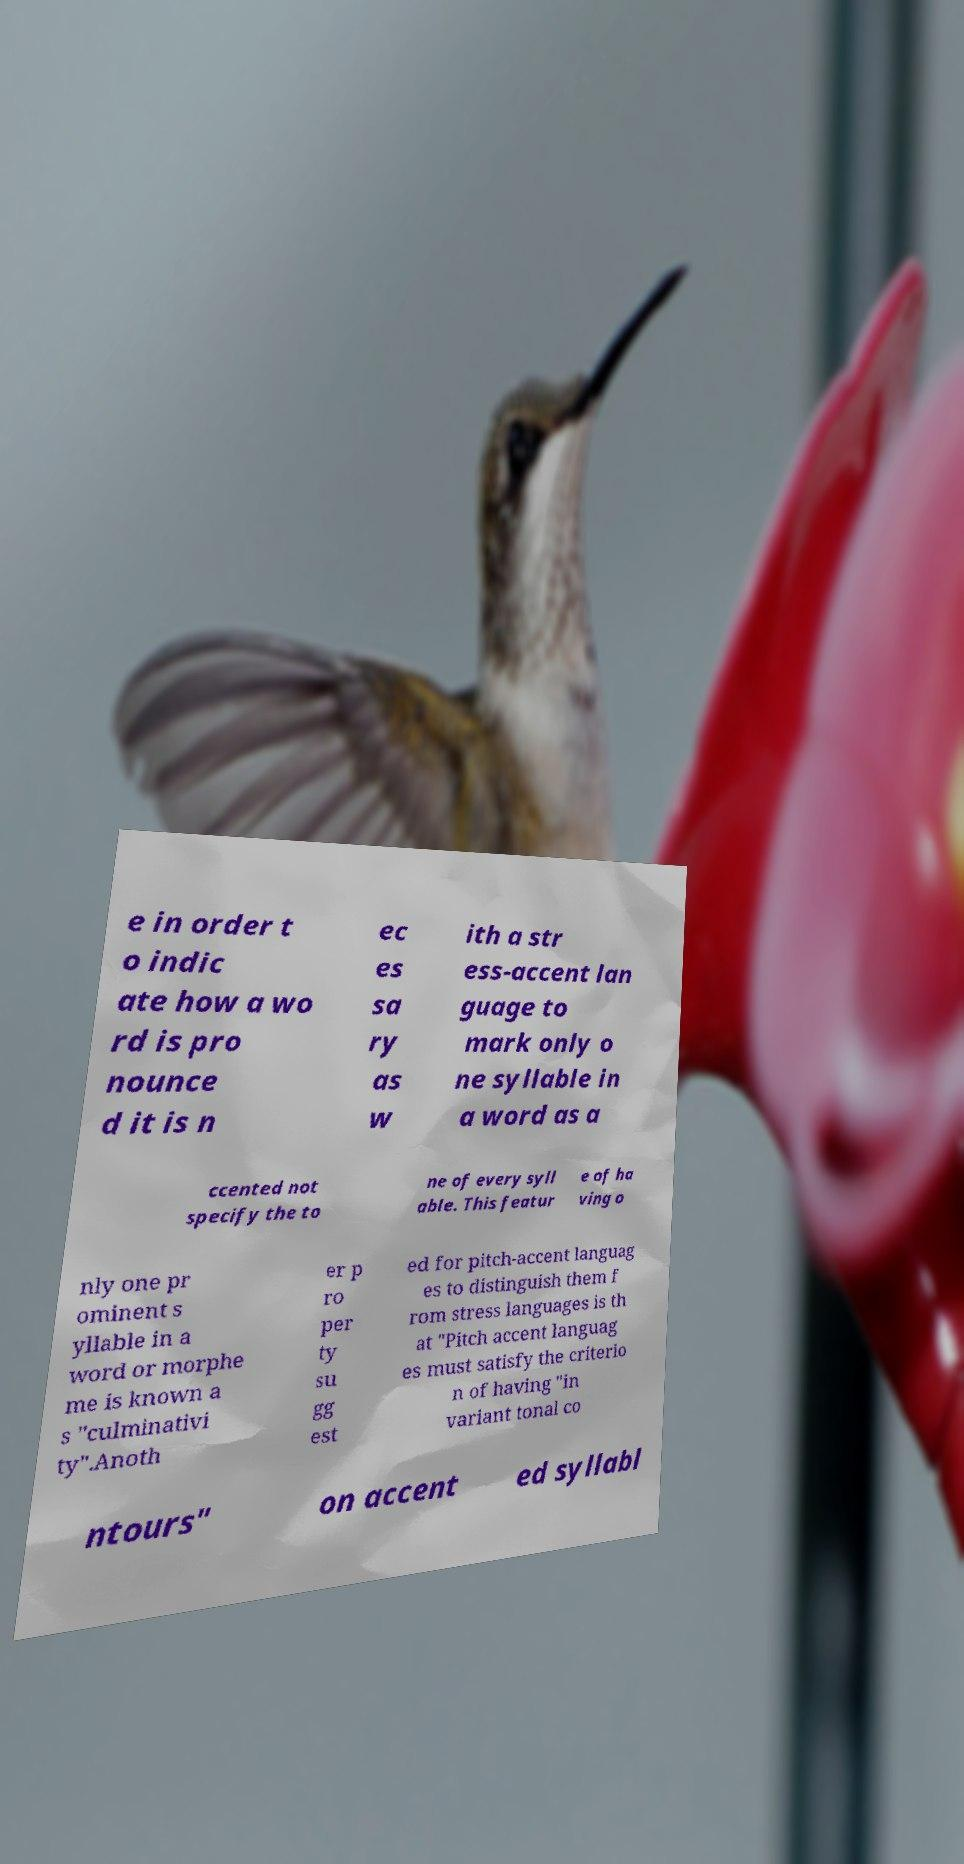I need the written content from this picture converted into text. Can you do that? e in order t o indic ate how a wo rd is pro nounce d it is n ec es sa ry as w ith a str ess-accent lan guage to mark only o ne syllable in a word as a ccented not specify the to ne of every syll able. This featur e of ha ving o nly one pr ominent s yllable in a word or morphe me is known a s "culminativi ty".Anoth er p ro per ty su gg est ed for pitch-accent languag es to distinguish them f rom stress languages is th at "Pitch accent languag es must satisfy the criterio n of having "in variant tonal co ntours" on accent ed syllabl 